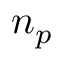<formula> <loc_0><loc_0><loc_500><loc_500>n _ { p }</formula> 